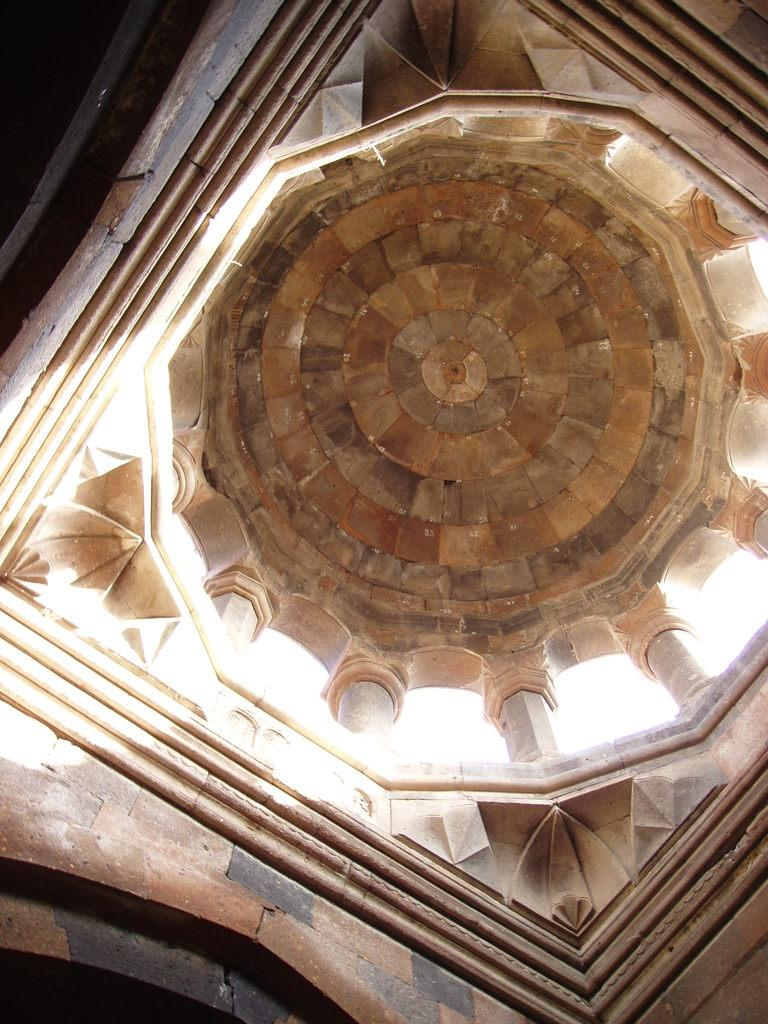What type of location is depicted in the image? The image is of the inside part of a fort. Can you describe any specific features or structures within the fort? Unfortunately, the provided facts do not include any specific details about the fort's interior. How many ears of corn can be seen growing inside the fort in the image? There is no corn present in the image, as it is a depiction of the inside part of a fort. 